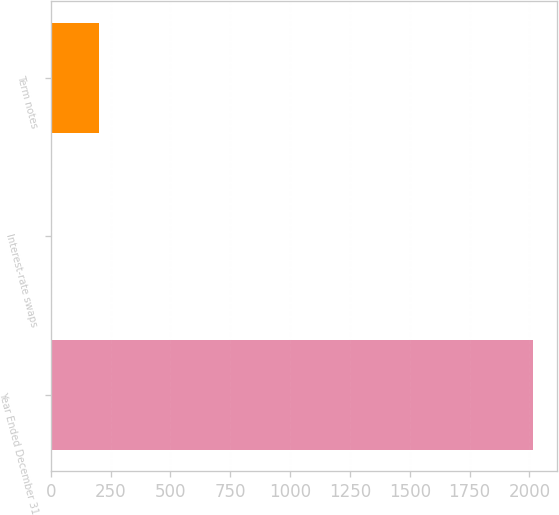Convert chart. <chart><loc_0><loc_0><loc_500><loc_500><bar_chart><fcel>Year Ended December 31<fcel>Interest-rate swaps<fcel>Term notes<nl><fcel>2013<fcel>0.7<fcel>201.93<nl></chart> 